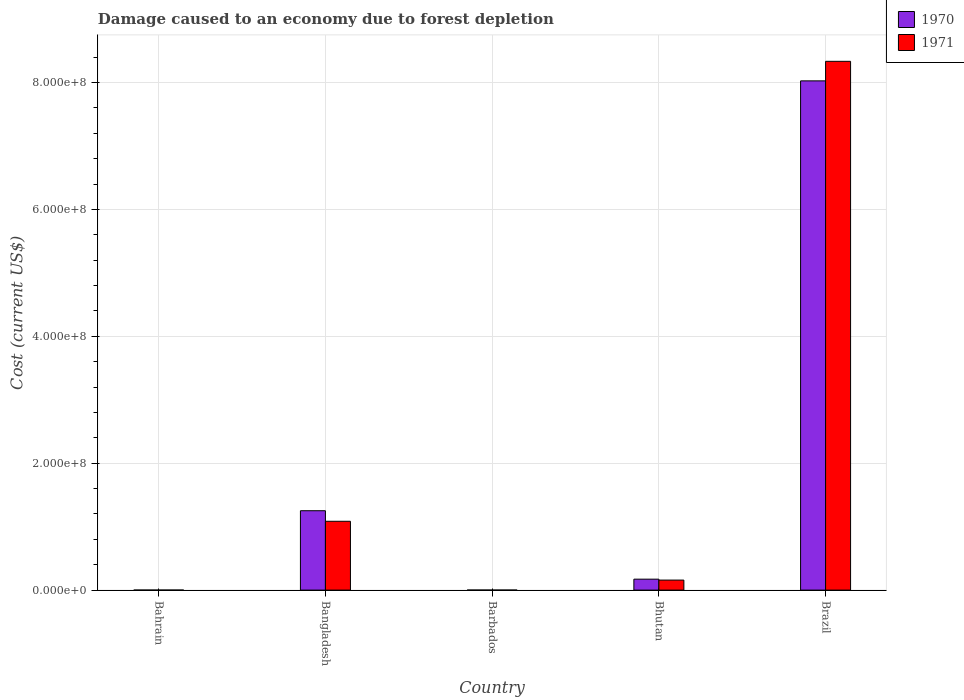How many bars are there on the 2nd tick from the left?
Your answer should be compact. 2. What is the label of the 1st group of bars from the left?
Your answer should be very brief. Bahrain. What is the cost of damage caused due to forest depletion in 1971 in Bahrain?
Give a very brief answer. 1.16e+04. Across all countries, what is the maximum cost of damage caused due to forest depletion in 1971?
Make the answer very short. 8.33e+08. Across all countries, what is the minimum cost of damage caused due to forest depletion in 1971?
Keep it short and to the point. 1.16e+04. In which country was the cost of damage caused due to forest depletion in 1970 maximum?
Keep it short and to the point. Brazil. In which country was the cost of damage caused due to forest depletion in 1971 minimum?
Keep it short and to the point. Bahrain. What is the total cost of damage caused due to forest depletion in 1970 in the graph?
Give a very brief answer. 9.45e+08. What is the difference between the cost of damage caused due to forest depletion in 1970 in Barbados and that in Brazil?
Make the answer very short. -8.03e+08. What is the difference between the cost of damage caused due to forest depletion in 1970 in Barbados and the cost of damage caused due to forest depletion in 1971 in Brazil?
Give a very brief answer. -8.33e+08. What is the average cost of damage caused due to forest depletion in 1970 per country?
Provide a short and direct response. 1.89e+08. What is the difference between the cost of damage caused due to forest depletion of/in 1970 and cost of damage caused due to forest depletion of/in 1971 in Bahrain?
Offer a very short reply. 3638.2. In how many countries, is the cost of damage caused due to forest depletion in 1970 greater than 200000000 US$?
Offer a terse response. 1. What is the ratio of the cost of damage caused due to forest depletion in 1970 in Bangladesh to that in Barbados?
Your answer should be very brief. 3378.68. What is the difference between the highest and the second highest cost of damage caused due to forest depletion in 1971?
Offer a very short reply. 7.25e+08. What is the difference between the highest and the lowest cost of damage caused due to forest depletion in 1971?
Offer a very short reply. 8.33e+08. In how many countries, is the cost of damage caused due to forest depletion in 1970 greater than the average cost of damage caused due to forest depletion in 1970 taken over all countries?
Provide a succinct answer. 1. Is the sum of the cost of damage caused due to forest depletion in 1970 in Bangladesh and Bhutan greater than the maximum cost of damage caused due to forest depletion in 1971 across all countries?
Make the answer very short. No. What does the 1st bar from the left in Bhutan represents?
Your answer should be very brief. 1970. What does the 2nd bar from the right in Bangladesh represents?
Your answer should be compact. 1970. What is the difference between two consecutive major ticks on the Y-axis?
Your answer should be very brief. 2.00e+08. Are the values on the major ticks of Y-axis written in scientific E-notation?
Offer a terse response. Yes. Does the graph contain any zero values?
Offer a very short reply. No. Does the graph contain grids?
Make the answer very short. Yes. How many legend labels are there?
Give a very brief answer. 2. What is the title of the graph?
Your answer should be compact. Damage caused to an economy due to forest depletion. What is the label or title of the X-axis?
Your answer should be compact. Country. What is the label or title of the Y-axis?
Keep it short and to the point. Cost (current US$). What is the Cost (current US$) of 1970 in Bahrain?
Offer a terse response. 1.53e+04. What is the Cost (current US$) of 1971 in Bahrain?
Your answer should be compact. 1.16e+04. What is the Cost (current US$) of 1970 in Bangladesh?
Offer a very short reply. 1.25e+08. What is the Cost (current US$) of 1971 in Bangladesh?
Provide a succinct answer. 1.08e+08. What is the Cost (current US$) in 1970 in Barbados?
Give a very brief answer. 3.70e+04. What is the Cost (current US$) in 1971 in Barbados?
Offer a very short reply. 2.86e+04. What is the Cost (current US$) of 1970 in Bhutan?
Offer a terse response. 1.72e+07. What is the Cost (current US$) of 1971 in Bhutan?
Give a very brief answer. 1.58e+07. What is the Cost (current US$) of 1970 in Brazil?
Ensure brevity in your answer.  8.03e+08. What is the Cost (current US$) of 1971 in Brazil?
Make the answer very short. 8.33e+08. Across all countries, what is the maximum Cost (current US$) of 1970?
Give a very brief answer. 8.03e+08. Across all countries, what is the maximum Cost (current US$) of 1971?
Your response must be concise. 8.33e+08. Across all countries, what is the minimum Cost (current US$) of 1970?
Your answer should be very brief. 1.53e+04. Across all countries, what is the minimum Cost (current US$) in 1971?
Make the answer very short. 1.16e+04. What is the total Cost (current US$) in 1970 in the graph?
Offer a very short reply. 9.45e+08. What is the total Cost (current US$) in 1971 in the graph?
Provide a succinct answer. 9.58e+08. What is the difference between the Cost (current US$) in 1970 in Bahrain and that in Bangladesh?
Your response must be concise. -1.25e+08. What is the difference between the Cost (current US$) in 1971 in Bahrain and that in Bangladesh?
Your answer should be compact. -1.08e+08. What is the difference between the Cost (current US$) of 1970 in Bahrain and that in Barbados?
Ensure brevity in your answer.  -2.18e+04. What is the difference between the Cost (current US$) in 1971 in Bahrain and that in Barbados?
Provide a succinct answer. -1.70e+04. What is the difference between the Cost (current US$) in 1970 in Bahrain and that in Bhutan?
Your answer should be very brief. -1.72e+07. What is the difference between the Cost (current US$) of 1971 in Bahrain and that in Bhutan?
Give a very brief answer. -1.58e+07. What is the difference between the Cost (current US$) of 1970 in Bahrain and that in Brazil?
Your answer should be compact. -8.03e+08. What is the difference between the Cost (current US$) of 1971 in Bahrain and that in Brazil?
Your response must be concise. -8.33e+08. What is the difference between the Cost (current US$) in 1970 in Bangladesh and that in Barbados?
Your answer should be compact. 1.25e+08. What is the difference between the Cost (current US$) of 1971 in Bangladesh and that in Barbados?
Offer a very short reply. 1.08e+08. What is the difference between the Cost (current US$) of 1970 in Bangladesh and that in Bhutan?
Your answer should be compact. 1.08e+08. What is the difference between the Cost (current US$) of 1971 in Bangladesh and that in Bhutan?
Keep it short and to the point. 9.27e+07. What is the difference between the Cost (current US$) in 1970 in Bangladesh and that in Brazil?
Keep it short and to the point. -6.77e+08. What is the difference between the Cost (current US$) in 1971 in Bangladesh and that in Brazil?
Offer a very short reply. -7.25e+08. What is the difference between the Cost (current US$) in 1970 in Barbados and that in Bhutan?
Offer a very short reply. -1.72e+07. What is the difference between the Cost (current US$) of 1971 in Barbados and that in Bhutan?
Your response must be concise. -1.57e+07. What is the difference between the Cost (current US$) of 1970 in Barbados and that in Brazil?
Offer a terse response. -8.03e+08. What is the difference between the Cost (current US$) in 1971 in Barbados and that in Brazil?
Your response must be concise. -8.33e+08. What is the difference between the Cost (current US$) in 1970 in Bhutan and that in Brazil?
Give a very brief answer. -7.85e+08. What is the difference between the Cost (current US$) of 1971 in Bhutan and that in Brazil?
Your answer should be compact. -8.18e+08. What is the difference between the Cost (current US$) in 1970 in Bahrain and the Cost (current US$) in 1971 in Bangladesh?
Keep it short and to the point. -1.08e+08. What is the difference between the Cost (current US$) of 1970 in Bahrain and the Cost (current US$) of 1971 in Barbados?
Provide a succinct answer. -1.34e+04. What is the difference between the Cost (current US$) in 1970 in Bahrain and the Cost (current US$) in 1971 in Bhutan?
Give a very brief answer. -1.58e+07. What is the difference between the Cost (current US$) of 1970 in Bahrain and the Cost (current US$) of 1971 in Brazil?
Ensure brevity in your answer.  -8.33e+08. What is the difference between the Cost (current US$) of 1970 in Bangladesh and the Cost (current US$) of 1971 in Barbados?
Make the answer very short. 1.25e+08. What is the difference between the Cost (current US$) in 1970 in Bangladesh and the Cost (current US$) in 1971 in Bhutan?
Offer a very short reply. 1.09e+08. What is the difference between the Cost (current US$) of 1970 in Bangladesh and the Cost (current US$) of 1971 in Brazil?
Give a very brief answer. -7.08e+08. What is the difference between the Cost (current US$) in 1970 in Barbados and the Cost (current US$) in 1971 in Bhutan?
Ensure brevity in your answer.  -1.57e+07. What is the difference between the Cost (current US$) in 1970 in Barbados and the Cost (current US$) in 1971 in Brazil?
Give a very brief answer. -8.33e+08. What is the difference between the Cost (current US$) of 1970 in Bhutan and the Cost (current US$) of 1971 in Brazil?
Provide a short and direct response. -8.16e+08. What is the average Cost (current US$) in 1970 per country?
Ensure brevity in your answer.  1.89e+08. What is the average Cost (current US$) of 1971 per country?
Make the answer very short. 1.92e+08. What is the difference between the Cost (current US$) of 1970 and Cost (current US$) of 1971 in Bahrain?
Offer a very short reply. 3638.2. What is the difference between the Cost (current US$) in 1970 and Cost (current US$) in 1971 in Bangladesh?
Provide a short and direct response. 1.66e+07. What is the difference between the Cost (current US$) in 1970 and Cost (current US$) in 1971 in Barbados?
Your answer should be compact. 8397.63. What is the difference between the Cost (current US$) in 1970 and Cost (current US$) in 1971 in Bhutan?
Provide a succinct answer. 1.47e+06. What is the difference between the Cost (current US$) in 1970 and Cost (current US$) in 1971 in Brazil?
Offer a terse response. -3.08e+07. What is the ratio of the Cost (current US$) in 1971 in Bahrain to that in Bangladesh?
Provide a short and direct response. 0. What is the ratio of the Cost (current US$) in 1970 in Bahrain to that in Barbados?
Your answer should be very brief. 0.41. What is the ratio of the Cost (current US$) of 1971 in Bahrain to that in Barbados?
Ensure brevity in your answer.  0.41. What is the ratio of the Cost (current US$) in 1970 in Bahrain to that in Bhutan?
Keep it short and to the point. 0. What is the ratio of the Cost (current US$) of 1971 in Bahrain to that in Bhutan?
Your response must be concise. 0. What is the ratio of the Cost (current US$) in 1971 in Bahrain to that in Brazil?
Your answer should be compact. 0. What is the ratio of the Cost (current US$) in 1970 in Bangladesh to that in Barbados?
Provide a short and direct response. 3378.68. What is the ratio of the Cost (current US$) in 1971 in Bangladesh to that in Barbados?
Keep it short and to the point. 3788.69. What is the ratio of the Cost (current US$) in 1970 in Bangladesh to that in Bhutan?
Provide a succinct answer. 7.26. What is the ratio of the Cost (current US$) of 1971 in Bangladesh to that in Bhutan?
Make the answer very short. 6.88. What is the ratio of the Cost (current US$) of 1970 in Bangladesh to that in Brazil?
Offer a very short reply. 0.16. What is the ratio of the Cost (current US$) in 1971 in Bangladesh to that in Brazil?
Ensure brevity in your answer.  0.13. What is the ratio of the Cost (current US$) of 1970 in Barbados to that in Bhutan?
Provide a succinct answer. 0. What is the ratio of the Cost (current US$) of 1971 in Barbados to that in Bhutan?
Give a very brief answer. 0. What is the ratio of the Cost (current US$) of 1971 in Barbados to that in Brazil?
Give a very brief answer. 0. What is the ratio of the Cost (current US$) in 1970 in Bhutan to that in Brazil?
Your response must be concise. 0.02. What is the ratio of the Cost (current US$) of 1971 in Bhutan to that in Brazil?
Your response must be concise. 0.02. What is the difference between the highest and the second highest Cost (current US$) in 1970?
Your response must be concise. 6.77e+08. What is the difference between the highest and the second highest Cost (current US$) in 1971?
Offer a very short reply. 7.25e+08. What is the difference between the highest and the lowest Cost (current US$) in 1970?
Provide a succinct answer. 8.03e+08. What is the difference between the highest and the lowest Cost (current US$) in 1971?
Make the answer very short. 8.33e+08. 